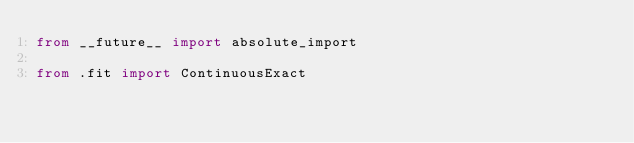<code> <loc_0><loc_0><loc_500><loc_500><_Python_>from __future__ import absolute_import

from .fit import ContinuousExact
</code> 